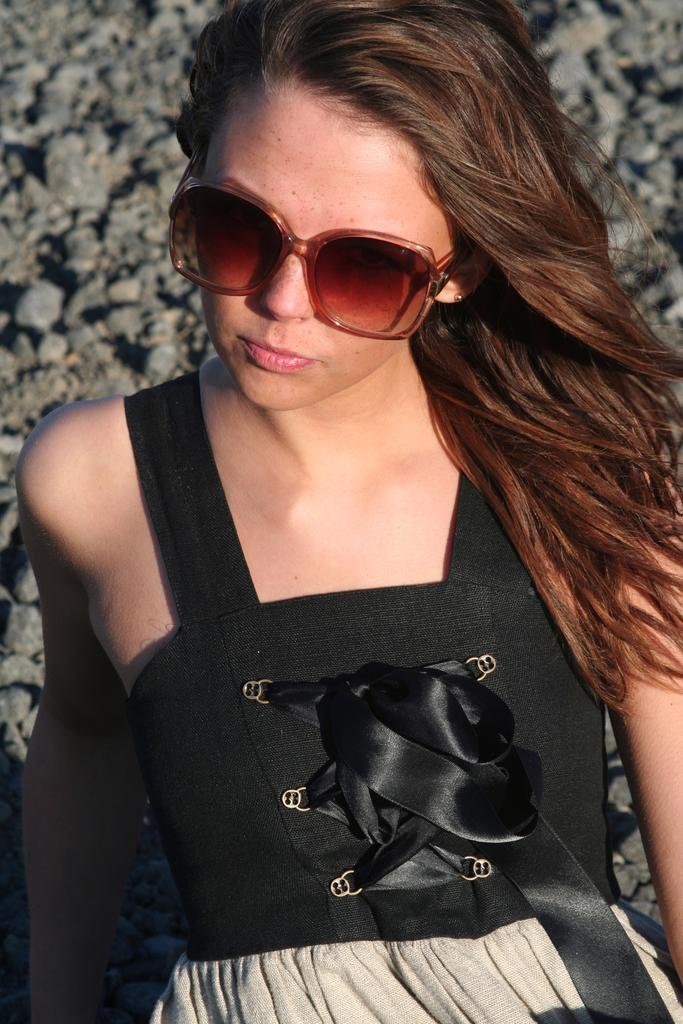Who is the main subject in the image? There is a woman in the image. What is the woman wearing on her face? The woman is wearing goggles. What color is the dress the woman is wearing? The woman is wearing a black dress. What position is the woman in? The woman is sitting on the floor. What type of natural elements can be seen in the image? There are stones visible in the top left of the image. What type of game is being played in the image? There is no game being played in the image; it features a woman sitting on the floor wearing goggles and a black dress. Where can you buy the end of the woman's dress in the image? There is no store or purchase involved in the image; it is a photograph of a woman wearing a black dress. 